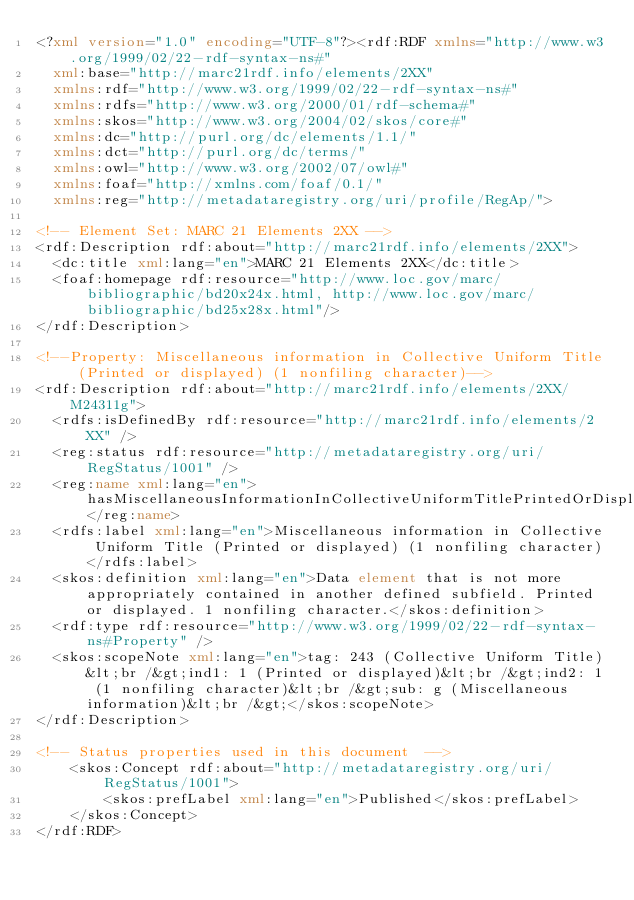<code> <loc_0><loc_0><loc_500><loc_500><_XML_><?xml version="1.0" encoding="UTF-8"?><rdf:RDF xmlns="http://www.w3.org/1999/02/22-rdf-syntax-ns#"
  xml:base="http://marc21rdf.info/elements/2XX"
  xmlns:rdf="http://www.w3.org/1999/02/22-rdf-syntax-ns#"
  xmlns:rdfs="http://www.w3.org/2000/01/rdf-schema#"
  xmlns:skos="http://www.w3.org/2004/02/skos/core#"
  xmlns:dc="http://purl.org/dc/elements/1.1/"
  xmlns:dct="http://purl.org/dc/terms/"
  xmlns:owl="http://www.w3.org/2002/07/owl#"
  xmlns:foaf="http://xmlns.com/foaf/0.1/"
  xmlns:reg="http://metadataregistry.org/uri/profile/RegAp/">

<!-- Element Set: MARC 21 Elements 2XX -->
<rdf:Description rdf:about="http://marc21rdf.info/elements/2XX">
  <dc:title xml:lang="en">MARC 21 Elements 2XX</dc:title>
  <foaf:homepage rdf:resource="http://www.loc.gov/marc/bibliographic/bd20x24x.html, http://www.loc.gov/marc/bibliographic/bd25x28x.html"/>
</rdf:Description>

<!--Property: Miscellaneous information in Collective Uniform Title (Printed or displayed) (1 nonfiling character)-->
<rdf:Description rdf:about="http://marc21rdf.info/elements/2XX/M24311g">
  <rdfs:isDefinedBy rdf:resource="http://marc21rdf.info/elements/2XX" />
  <reg:status rdf:resource="http://metadataregistry.org/uri/RegStatus/1001" />
  <reg:name xml:lang="en">hasMiscellaneousInformationInCollectiveUniformTitlePrintedOrDisplayed1NonfilingCharacter</reg:name>
  <rdfs:label xml:lang="en">Miscellaneous information in Collective Uniform Title (Printed or displayed) (1 nonfiling character)</rdfs:label>
  <skos:definition xml:lang="en">Data element that is not more appropriately contained in another defined subfield. Printed or displayed. 1 nonfiling character.</skos:definition>
  <rdf:type rdf:resource="http://www.w3.org/1999/02/22-rdf-syntax-ns#Property" />
  <skos:scopeNote xml:lang="en">tag: 243 (Collective Uniform Title)&lt;br /&gt;ind1: 1 (Printed or displayed)&lt;br /&gt;ind2: 1 (1 nonfiling character)&lt;br /&gt;sub: g (Miscellaneous information)&lt;br /&gt;</skos:scopeNote>
</rdf:Description>

<!-- Status properties used in this document  -->
    <skos:Concept rdf:about="http://metadataregistry.org/uri/RegStatus/1001">
        <skos:prefLabel xml:lang="en">Published</skos:prefLabel>
    </skos:Concept>
</rdf:RDF></code> 